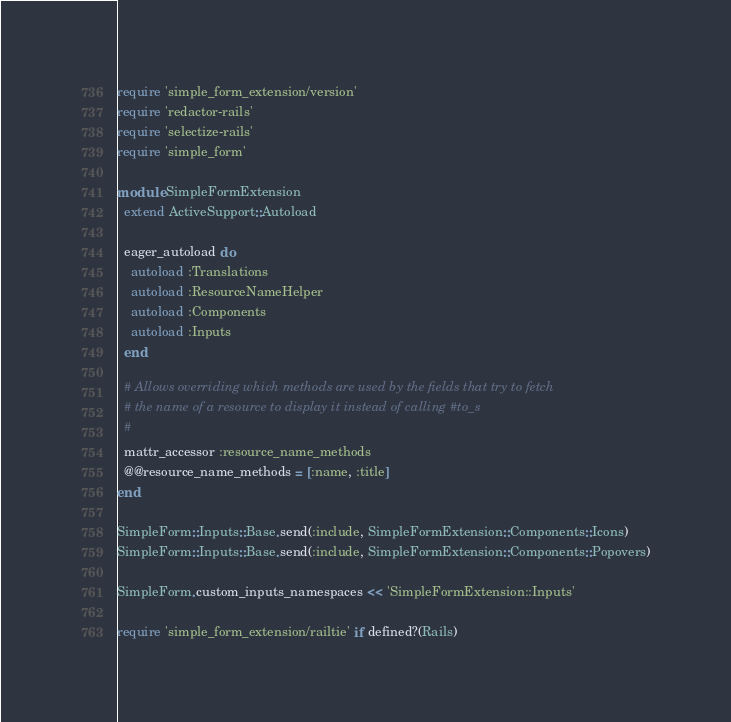Convert code to text. <code><loc_0><loc_0><loc_500><loc_500><_Ruby_>require 'simple_form_extension/version'
require 'redactor-rails'
require 'selectize-rails'
require 'simple_form'

module SimpleFormExtension
  extend ActiveSupport::Autoload

  eager_autoload do
    autoload :Translations
    autoload :ResourceNameHelper
    autoload :Components
    autoload :Inputs
  end

  # Allows overriding which methods are used by the fields that try to fetch
  # the name of a resource to display it instead of calling #to_s
  #
  mattr_accessor :resource_name_methods
  @@resource_name_methods = [:name, :title]
end

SimpleForm::Inputs::Base.send(:include, SimpleFormExtension::Components::Icons)
SimpleForm::Inputs::Base.send(:include, SimpleFormExtension::Components::Popovers)

SimpleForm.custom_inputs_namespaces << 'SimpleFormExtension::Inputs'

require 'simple_form_extension/railtie' if defined?(Rails)
</code> 